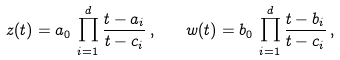Convert formula to latex. <formula><loc_0><loc_0><loc_500><loc_500>z ( t ) = a _ { 0 } \, \prod _ { i = 1 } ^ { d } \frac { t - a _ { i } } { t - c _ { i } } \, , \quad w ( t ) = b _ { 0 } \, \prod _ { i = 1 } ^ { d } \frac { t - b _ { i } } { t - c _ { i } } \, ,</formula> 